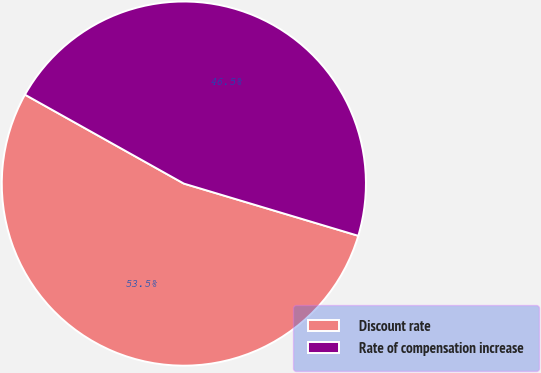Convert chart to OTSL. <chart><loc_0><loc_0><loc_500><loc_500><pie_chart><fcel>Discount rate<fcel>Rate of compensation increase<nl><fcel>53.49%<fcel>46.51%<nl></chart> 